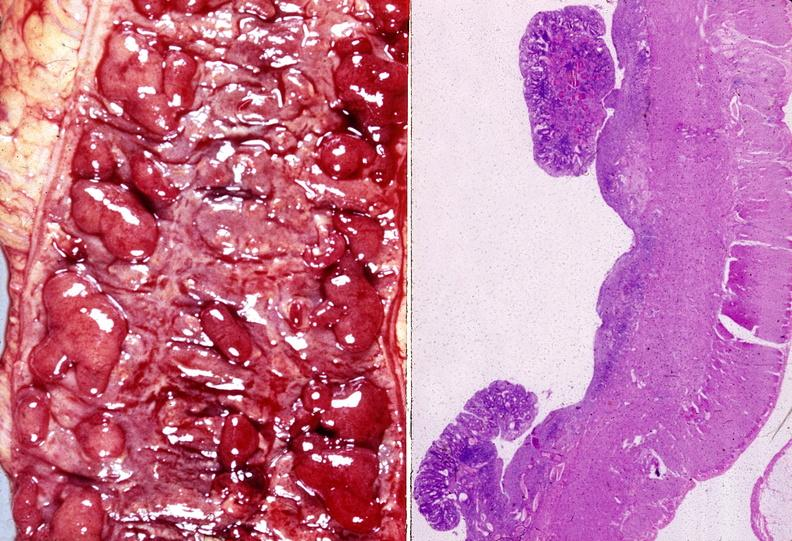s retroperitoneal leiomyosarcoma present?
Answer the question using a single word or phrase. No 